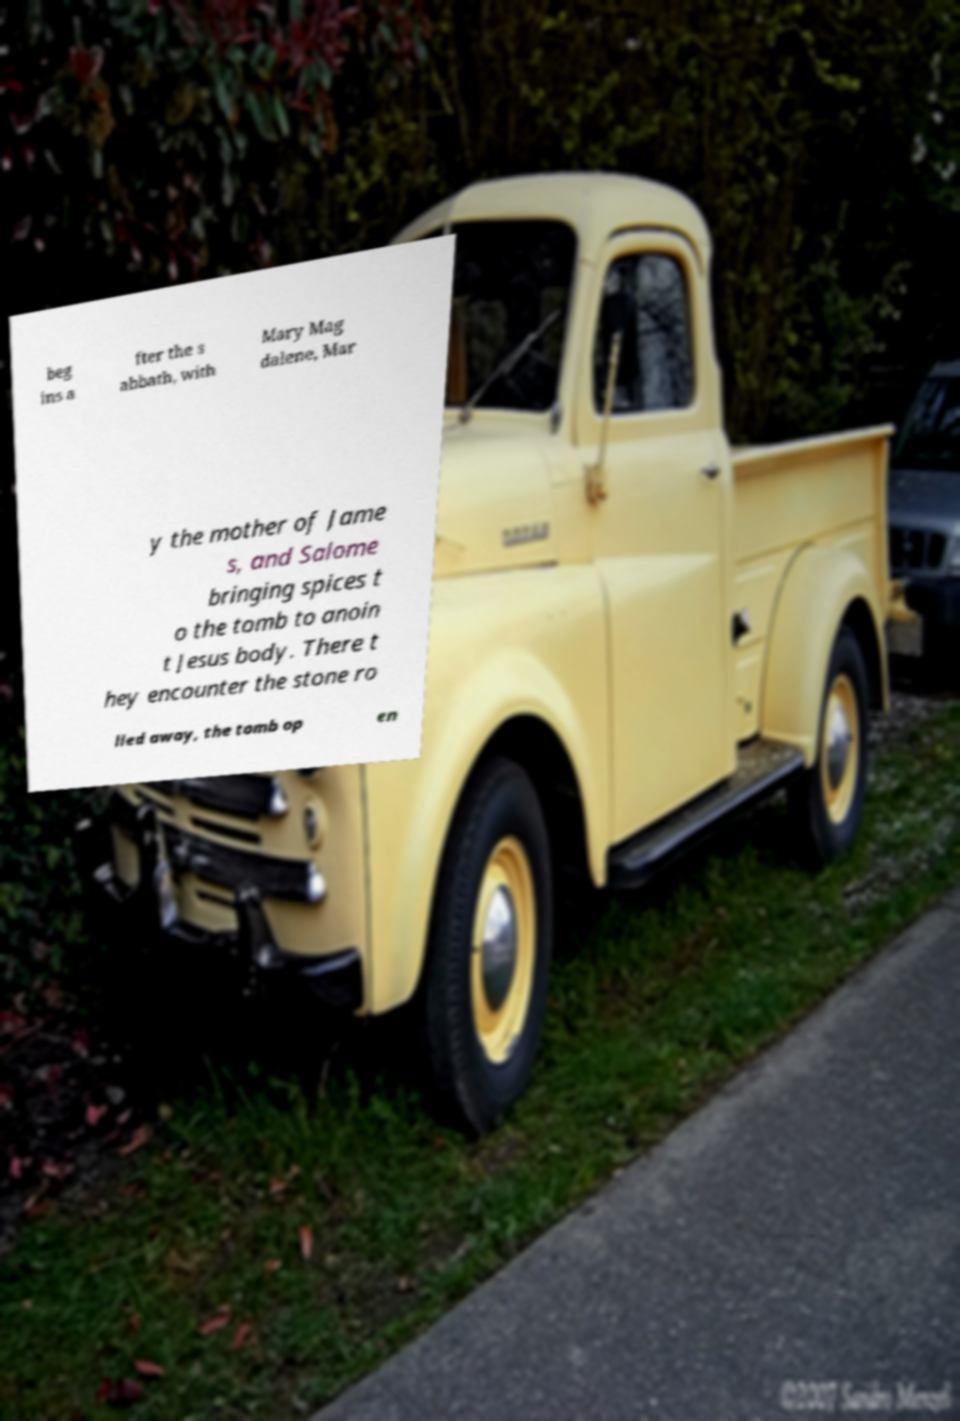For documentation purposes, I need the text within this image transcribed. Could you provide that? beg ins a fter the s abbath, with Mary Mag dalene, Mar y the mother of Jame s, and Salome bringing spices t o the tomb to anoin t Jesus body. There t hey encounter the stone ro lled away, the tomb op en 